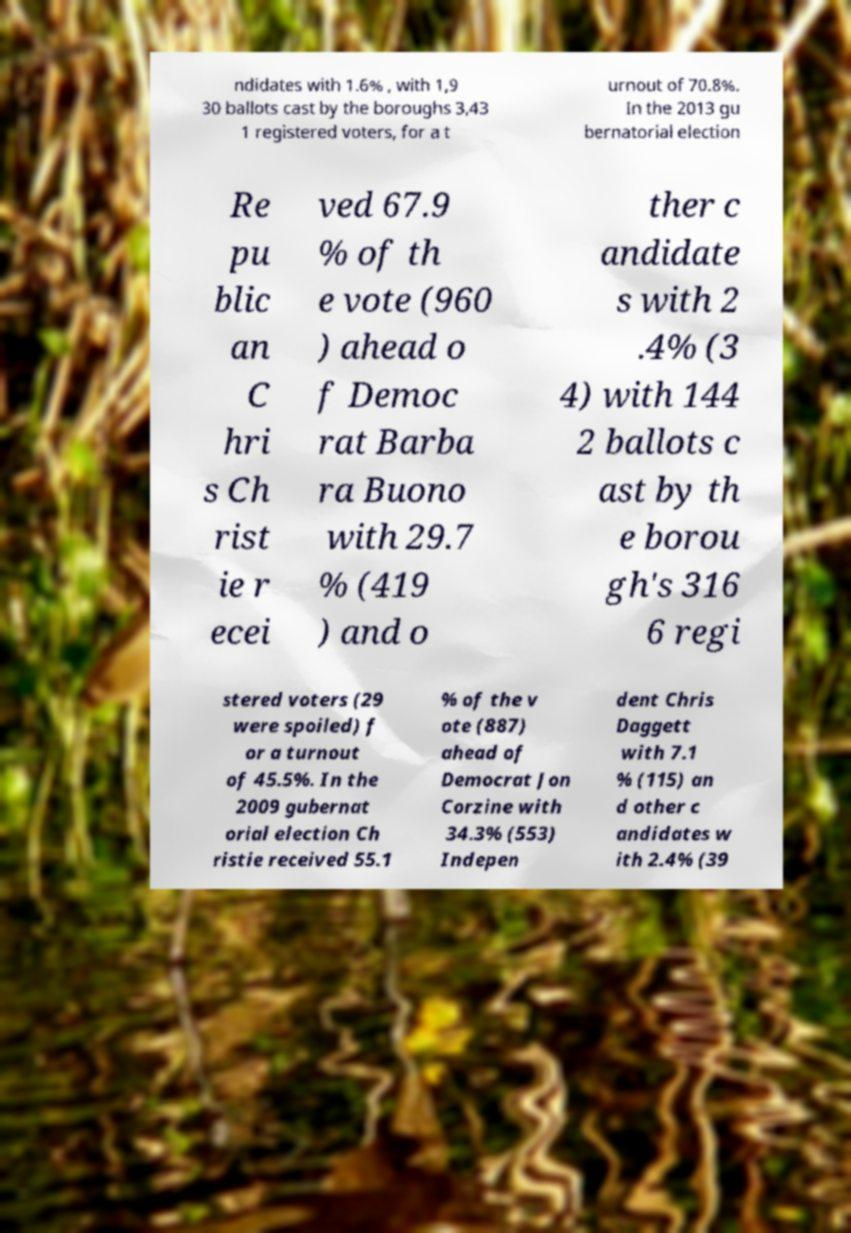Please identify and transcribe the text found in this image. ndidates with 1.6% , with 1,9 30 ballots cast by the boroughs 3,43 1 registered voters, for a t urnout of 70.8%. In the 2013 gu bernatorial election Re pu blic an C hri s Ch rist ie r ecei ved 67.9 % of th e vote (960 ) ahead o f Democ rat Barba ra Buono with 29.7 % (419 ) and o ther c andidate s with 2 .4% (3 4) with 144 2 ballots c ast by th e borou gh's 316 6 regi stered voters (29 were spoiled) f or a turnout of 45.5%. In the 2009 gubernat orial election Ch ristie received 55.1 % of the v ote (887) ahead of Democrat Jon Corzine with 34.3% (553) Indepen dent Chris Daggett with 7.1 % (115) an d other c andidates w ith 2.4% (39 